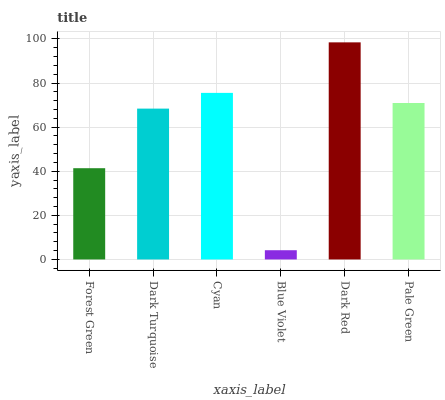Is Blue Violet the minimum?
Answer yes or no. Yes. Is Dark Red the maximum?
Answer yes or no. Yes. Is Dark Turquoise the minimum?
Answer yes or no. No. Is Dark Turquoise the maximum?
Answer yes or no. No. Is Dark Turquoise greater than Forest Green?
Answer yes or no. Yes. Is Forest Green less than Dark Turquoise?
Answer yes or no. Yes. Is Forest Green greater than Dark Turquoise?
Answer yes or no. No. Is Dark Turquoise less than Forest Green?
Answer yes or no. No. Is Pale Green the high median?
Answer yes or no. Yes. Is Dark Turquoise the low median?
Answer yes or no. Yes. Is Blue Violet the high median?
Answer yes or no. No. Is Blue Violet the low median?
Answer yes or no. No. 